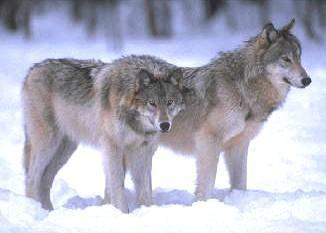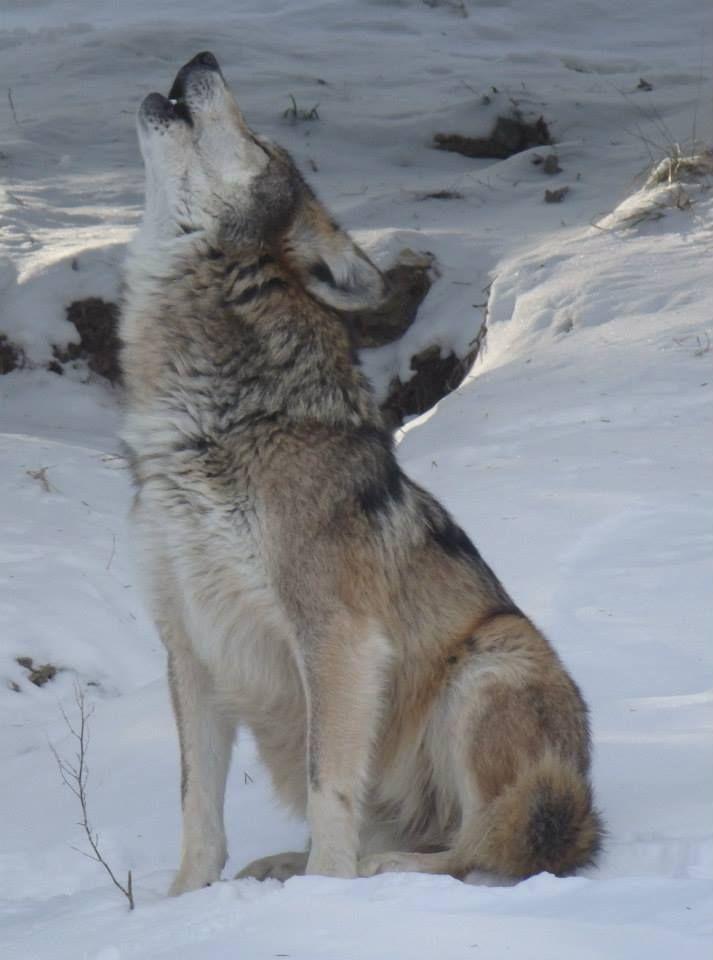The first image is the image on the left, the second image is the image on the right. Considering the images on both sides, is "There are three wolves" valid? Answer yes or no. Yes. 